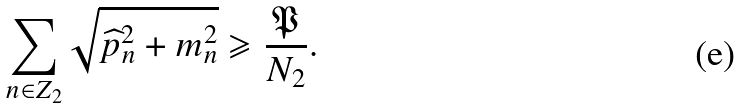<formula> <loc_0><loc_0><loc_500><loc_500>\sum _ { n \in Z _ { 2 } } \sqrt { \widehat { p } _ { n } ^ { 2 } + m _ { n } ^ { 2 } } \geqslant \frac { \mathfrak { P } } { N _ { 2 } } .</formula> 